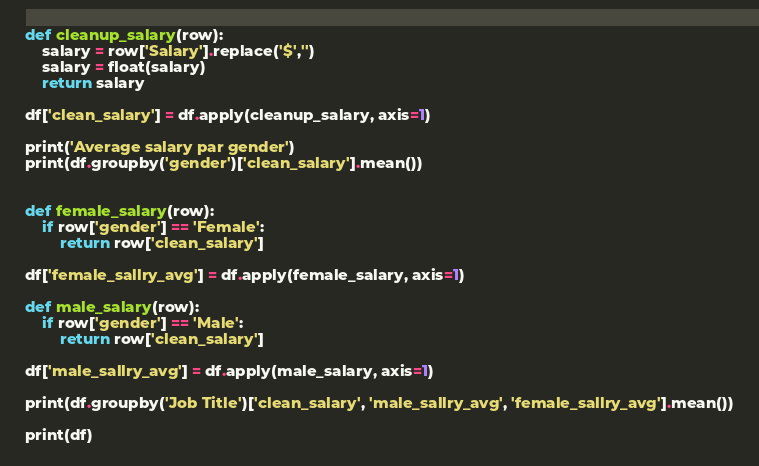<code> <loc_0><loc_0><loc_500><loc_500><_Python_>def cleanup_salary(row):
    salary = row['Salary'].replace('$','')
    salary = float(salary)
    return salary

df['clean_salary'] = df.apply(cleanup_salary, axis=1)

print('Average salary par gender')
print(df.groupby('gender')['clean_salary'].mean())


def female_salary(row):
    if row['gender'] == 'Female':
        return row['clean_salary']

df['female_sallry_avg'] = df.apply(female_salary, axis=1)

def male_salary(row):
    if row['gender'] == 'Male':
        return row['clean_salary']

df['male_sallry_avg'] = df.apply(male_salary, axis=1)

print(df.groupby('Job Title')['clean_salary', 'male_sallry_avg', 'female_sallry_avg'].mean())

print(df)
</code> 